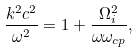<formula> <loc_0><loc_0><loc_500><loc_500>\frac { k ^ { 2 } c ^ { 2 } } { \omega ^ { 2 } } = 1 + \frac { \Omega _ { i } ^ { 2 } } { \omega \omega _ { c p } } ,</formula> 